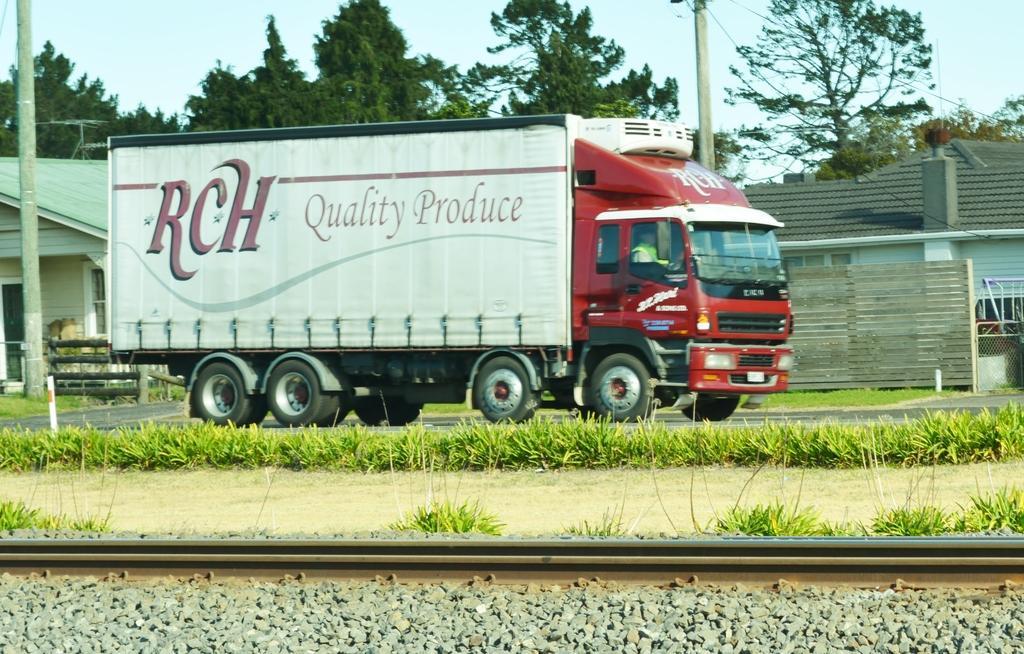Describe this image in one or two sentences. In this picture I can see a person sitting inside a vehicle. I can see planets, railway tracks, buildings, poles, trees, and in the background there is the sky. 